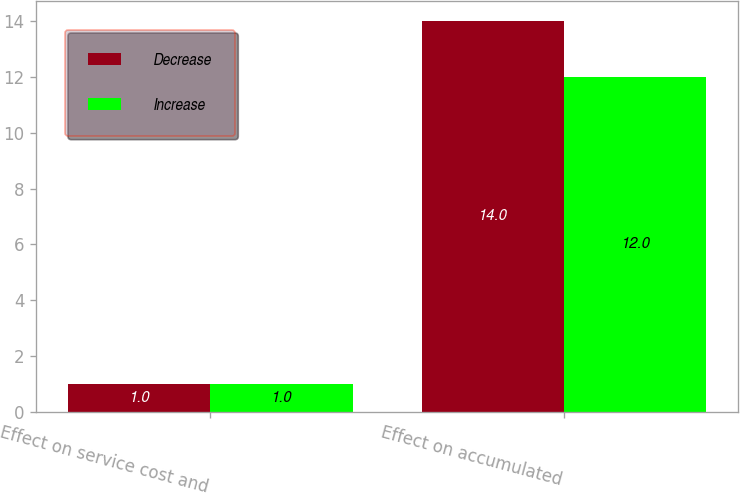Convert chart to OTSL. <chart><loc_0><loc_0><loc_500><loc_500><stacked_bar_chart><ecel><fcel>Effect on service cost and<fcel>Effect on accumulated<nl><fcel>Decrease<fcel>1<fcel>14<nl><fcel>Increase<fcel>1<fcel>12<nl></chart> 